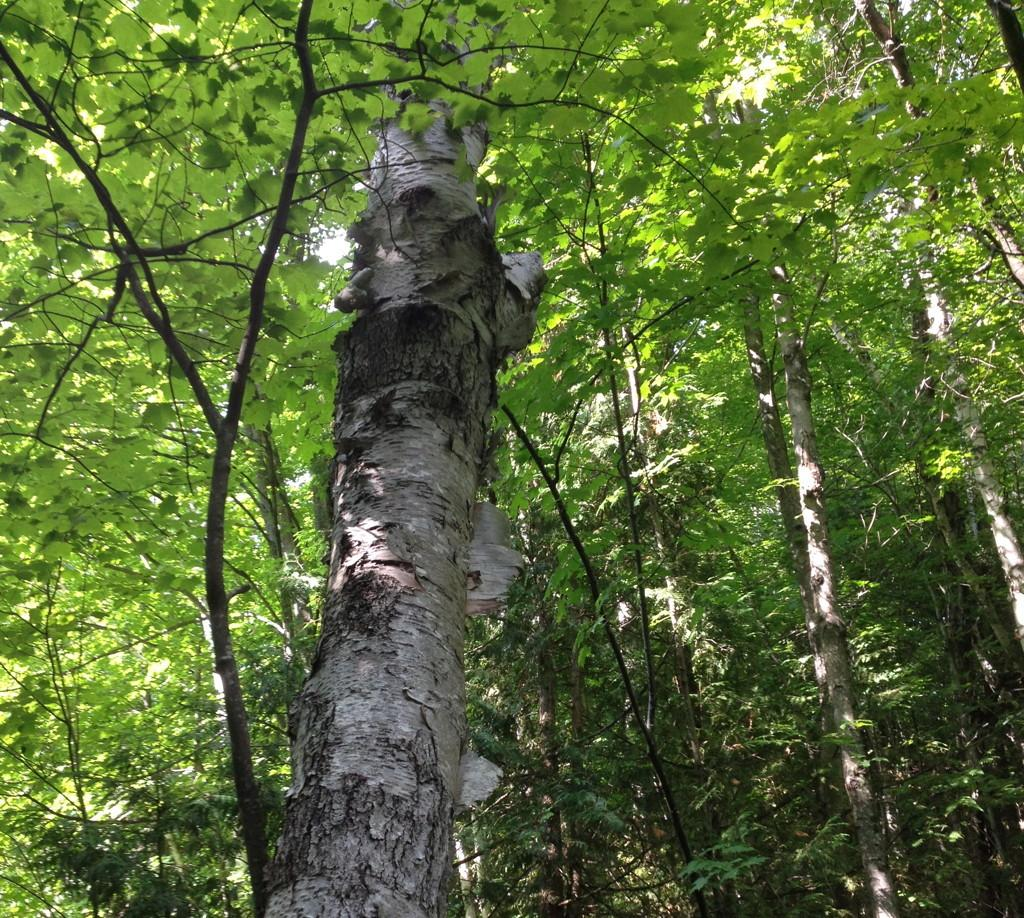What type of vegetation can be seen in the image? There are trees in the image. What arithmetic problem is being solved by the trees in the image? There is no arithmetic problem being solved by the trees in the image, as trees are living organisms and do not perform arithmetic. 